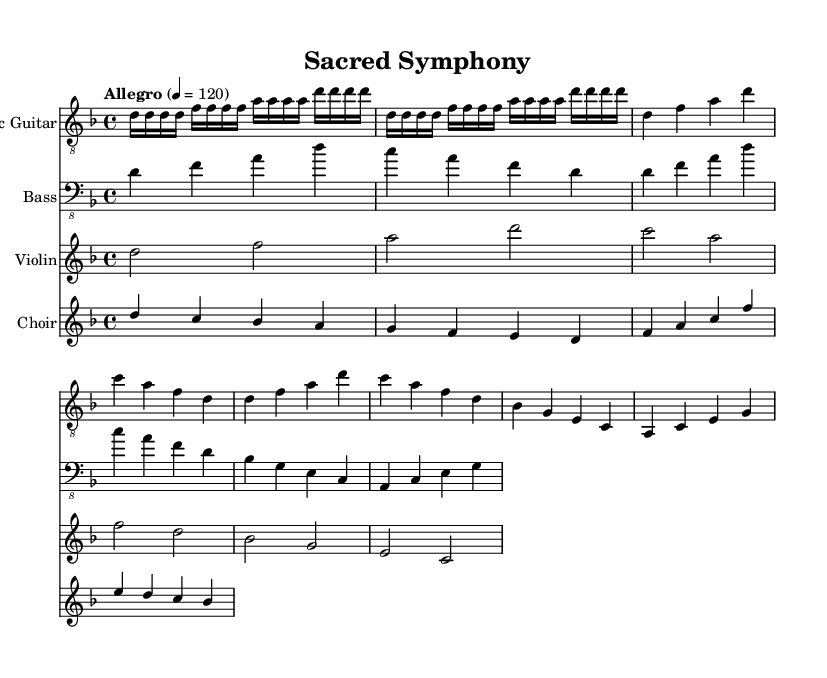What is the key signature of this music? The key signature is D minor, which contains one flat (B flat). You can determine this by looking at the key signature symbol at the beginning of the staff.
Answer: D minor What is the time signature of this music? The time signature is 4/4, which is indicated at the beginning of the score. This means there are four beats per measure, and the quarter note gets one beat.
Answer: 4/4 What is the tempo marking for this piece? The tempo marking indicates "Allegro" with a metronome marking of 120 beats per minute, shown at the beginning. "Allegro" signifies a fast tempo.
Answer: Allegro 4 = 120 How many measures are there in the main sections played by the electric guitar? By counting the distinct measures in the electric guitar part, there are 8 measures in total. Each line of music typically represents a set of measures.
Answer: 8 Which instrument plays the first melody line? The first melody line is played by the electric guitar as indicated in the score, which is the first staff listed.
Answer: Electric Guitar What text is associated with the choir part? The text associated with the choir is "Do -- mi -- nus pas -- tor me -- us ni -- hil mi -- hi de -- e -- rit," which is indicated under the choir staff.
Answer: "Do -- mi -- nus pas -- tor me -- us ni -- hil mi -- hi de -- e -- rit." What type of harmony is likely to characterize symphonic metal, given the orchestration here? Given the orchestration with electric guitar, bass, violin, and choir, the harmony is likely to be rich and layered, typical for symphonic metal which often combines orchestral elements with metal instrumentation.
Answer: Rich and layered 